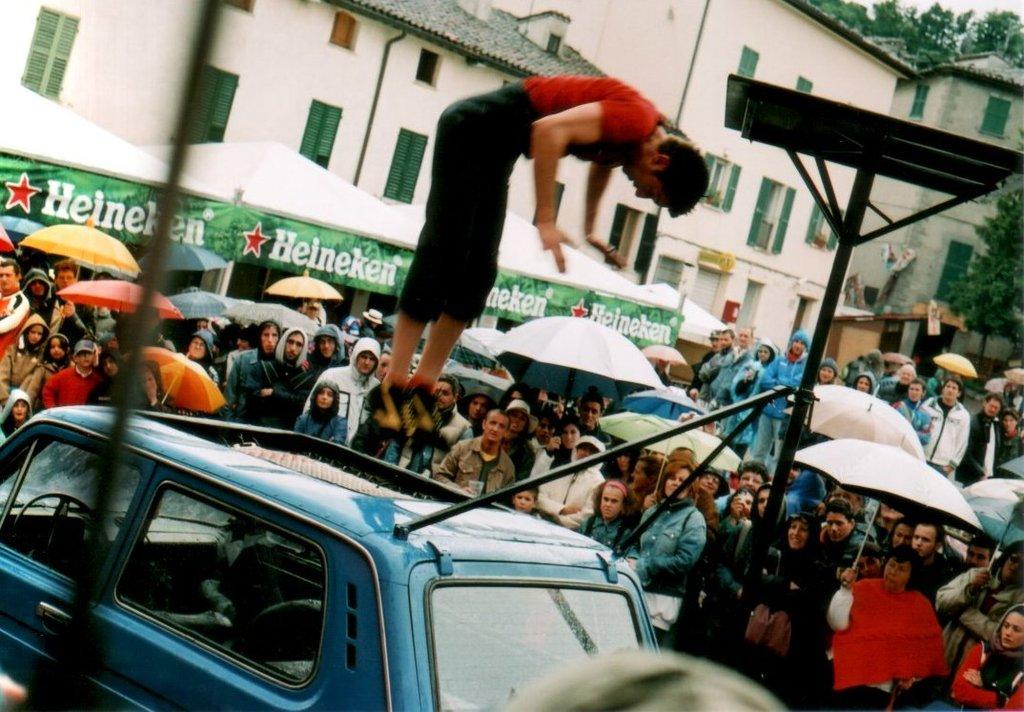What does it say next to the red stars?
Provide a succinct answer. Heineken. It says heineken?
Your answer should be very brief. Yes. 